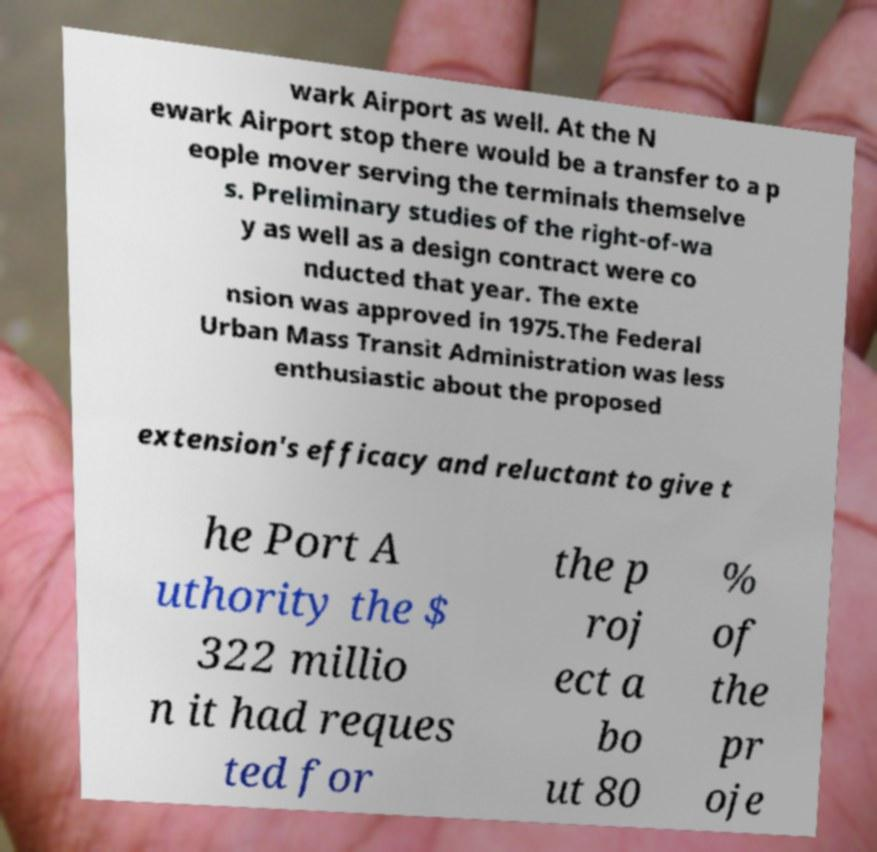Please read and relay the text visible in this image. What does it say? wark Airport as well. At the N ewark Airport stop there would be a transfer to a p eople mover serving the terminals themselve s. Preliminary studies of the right-of-wa y as well as a design contract were co nducted that year. The exte nsion was approved in 1975.The Federal Urban Mass Transit Administration was less enthusiastic about the proposed extension's efficacy and reluctant to give t he Port A uthority the $ 322 millio n it had reques ted for the p roj ect a bo ut 80 % of the pr oje 